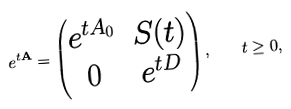Convert formula to latex. <formula><loc_0><loc_0><loc_500><loc_500>e ^ { t \mathbf A } = \begin{pmatrix} e ^ { t { A _ { 0 } } } & S ( t ) \\ 0 & e ^ { t D } \end{pmatrix} , \quad t \geq 0 ,</formula> 